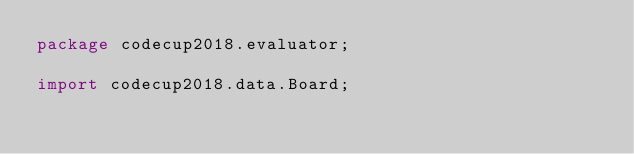Convert code to text. <code><loc_0><loc_0><loc_500><loc_500><_Java_>package codecup2018.evaluator;

import codecup2018.data.Board;
</code> 